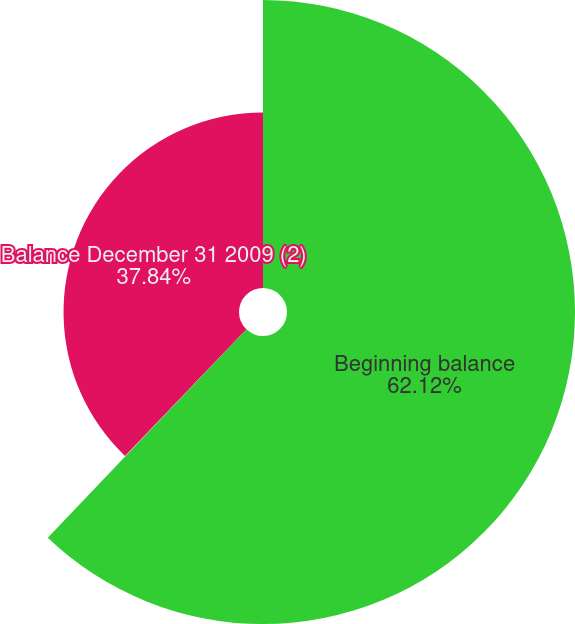Convert chart to OTSL. <chart><loc_0><loc_0><loc_500><loc_500><pie_chart><fcel>Beginning balance<fcel>Builds (reductions) to the<fcel>Balance December 31 2009 (2)<nl><fcel>62.11%<fcel>0.04%<fcel>37.84%<nl></chart> 